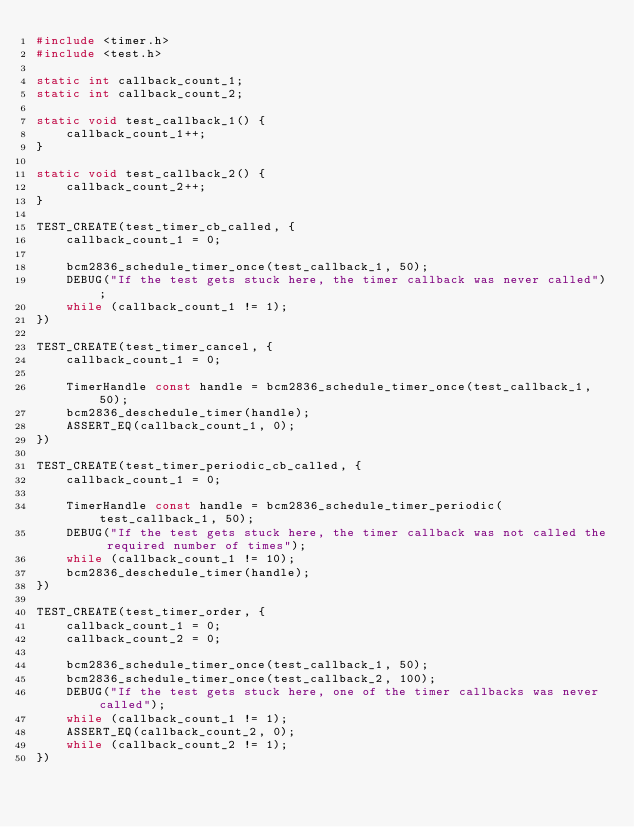<code> <loc_0><loc_0><loc_500><loc_500><_C_>#include <timer.h>
#include <test.h>

static int callback_count_1;
static int callback_count_2;

static void test_callback_1() {
    callback_count_1++;
}

static void test_callback_2() {
    callback_count_2++;
}

TEST_CREATE(test_timer_cb_called, {
    callback_count_1 = 0;

    bcm2836_schedule_timer_once(test_callback_1, 50);
    DEBUG("If the test gets stuck here, the timer callback was never called");
    while (callback_count_1 != 1);
})

TEST_CREATE(test_timer_cancel, {
    callback_count_1 = 0;

    TimerHandle const handle = bcm2836_schedule_timer_once(test_callback_1, 50);
    bcm2836_deschedule_timer(handle);
    ASSERT_EQ(callback_count_1, 0);
})

TEST_CREATE(test_timer_periodic_cb_called, {
    callback_count_1 = 0;

    TimerHandle const handle = bcm2836_schedule_timer_periodic(test_callback_1, 50);
    DEBUG("If the test gets stuck here, the timer callback was not called the required number of times");
    while (callback_count_1 != 10);
    bcm2836_deschedule_timer(handle);
})

TEST_CREATE(test_timer_order, {
    callback_count_1 = 0;
    callback_count_2 = 0;

    bcm2836_schedule_timer_once(test_callback_1, 50);
    bcm2836_schedule_timer_once(test_callback_2, 100);
    DEBUG("If the test gets stuck here, one of the timer callbacks was never called");
    while (callback_count_1 != 1);
    ASSERT_EQ(callback_count_2, 0);
    while (callback_count_2 != 1);
})
</code> 